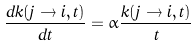Convert formula to latex. <formula><loc_0><loc_0><loc_500><loc_500>\frac { d k ( j \to i , t ) } { d t } = \alpha \frac { k ( j \to i , t ) } { t }</formula> 